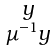Convert formula to latex. <formula><loc_0><loc_0><loc_500><loc_500>\begin{smallmatrix} y \\ \mu ^ { - 1 } y \end{smallmatrix}</formula> 